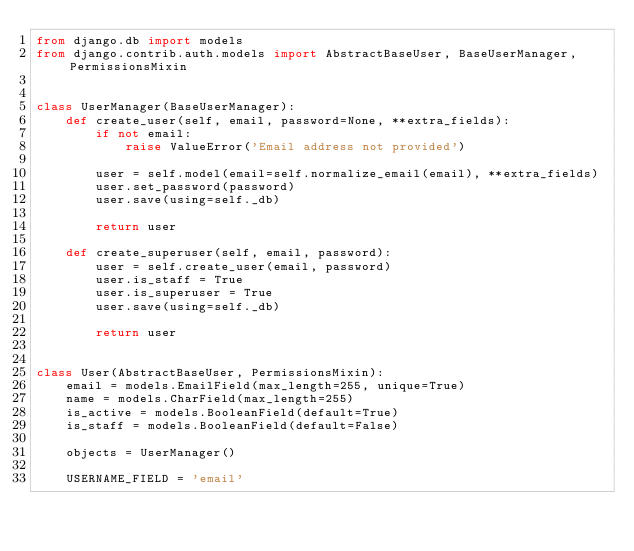<code> <loc_0><loc_0><loc_500><loc_500><_Python_>from django.db import models
from django.contrib.auth.models import AbstractBaseUser, BaseUserManager, PermissionsMixin


class UserManager(BaseUserManager):
    def create_user(self, email, password=None, **extra_fields):
        if not email:
            raise ValueError('Email address not provided')

        user = self.model(email=self.normalize_email(email), **extra_fields)
        user.set_password(password)
        user.save(using=self._db)

        return user

    def create_superuser(self, email, password):
        user = self.create_user(email, password)
        user.is_staff = True
        user.is_superuser = True
        user.save(using=self._db)

        return user


class User(AbstractBaseUser, PermissionsMixin):
    email = models.EmailField(max_length=255, unique=True)
    name = models.CharField(max_length=255)
    is_active = models.BooleanField(default=True)
    is_staff = models.BooleanField(default=False)

    objects = UserManager()

    USERNAME_FIELD = 'email'
</code> 